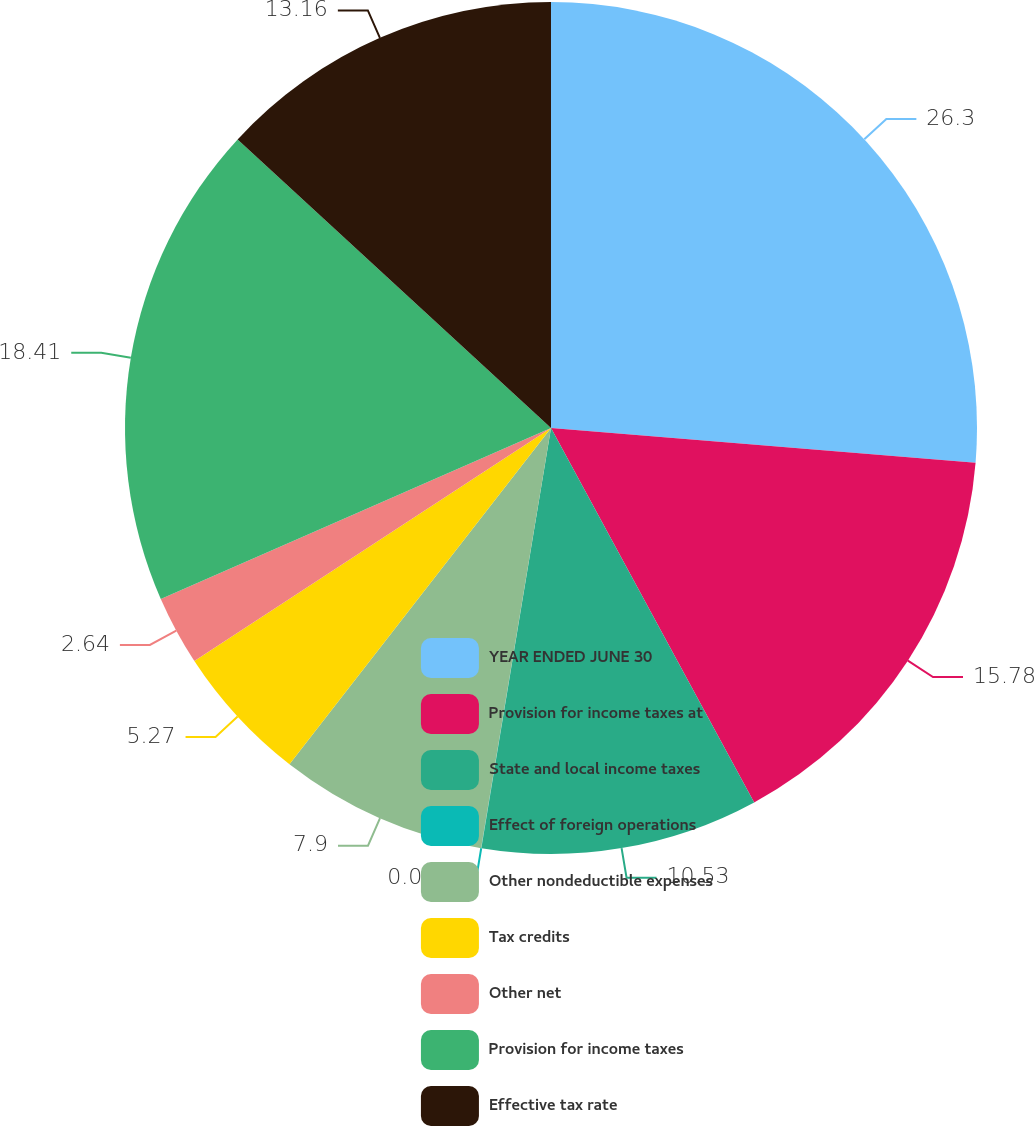<chart> <loc_0><loc_0><loc_500><loc_500><pie_chart><fcel>YEAR ENDED JUNE 30<fcel>Provision for income taxes at<fcel>State and local income taxes<fcel>Effect of foreign operations<fcel>Other nondeductible expenses<fcel>Tax credits<fcel>Other net<fcel>Provision for income taxes<fcel>Effective tax rate<nl><fcel>26.31%<fcel>15.79%<fcel>10.53%<fcel>0.01%<fcel>7.9%<fcel>5.27%<fcel>2.64%<fcel>18.42%<fcel>13.16%<nl></chart> 